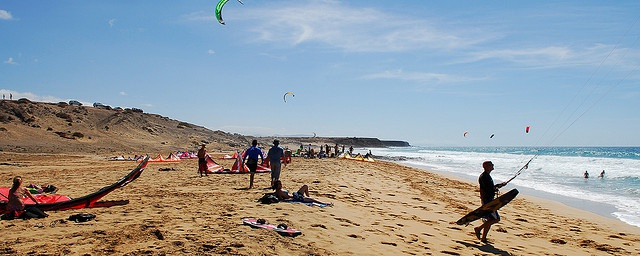Describe the objects in this image and their specific colors. I can see kite in gray, black, maroon, salmon, and red tones, people in gray, black, maroon, and brown tones, people in gray, black, maroon, and brown tones, surfboard in gray, black, maroon, and tan tones, and people in gray, black, darkgray, and lightgray tones in this image. 